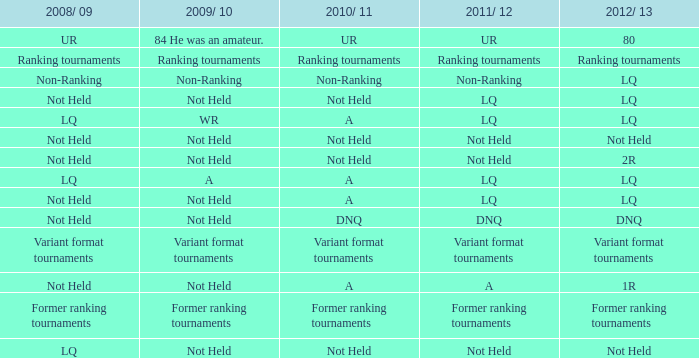Write the full table. {'header': ['2008/ 09', '2009/ 10', '2010/ 11', '2011/ 12', '2012/ 13'], 'rows': [['UR', '84 He was an amateur.', 'UR', 'UR', '80'], ['Ranking tournaments', 'Ranking tournaments', 'Ranking tournaments', 'Ranking tournaments', 'Ranking tournaments'], ['Non-Ranking', 'Non-Ranking', 'Non-Ranking', 'Non-Ranking', 'LQ'], ['Not Held', 'Not Held', 'Not Held', 'LQ', 'LQ'], ['LQ', 'WR', 'A', 'LQ', 'LQ'], ['Not Held', 'Not Held', 'Not Held', 'Not Held', 'Not Held'], ['Not Held', 'Not Held', 'Not Held', 'Not Held', '2R'], ['LQ', 'A', 'A', 'LQ', 'LQ'], ['Not Held', 'Not Held', 'A', 'LQ', 'LQ'], ['Not Held', 'Not Held', 'DNQ', 'DNQ', 'DNQ'], ['Variant format tournaments', 'Variant format tournaments', 'Variant format tournaments', 'Variant format tournaments', 'Variant format tournaments'], ['Not Held', 'Not Held', 'A', 'A', '1R'], ['Former ranking tournaments', 'Former ranking tournaments', 'Former ranking tournaments', 'Former ranking tournaments', 'Former ranking tournaments'], ['LQ', 'Not Held', 'Not Held', 'Not Held', 'Not Held']]} When the 2008/ 09 has non-ranking what is the 2009/ 10? Non-Ranking. 